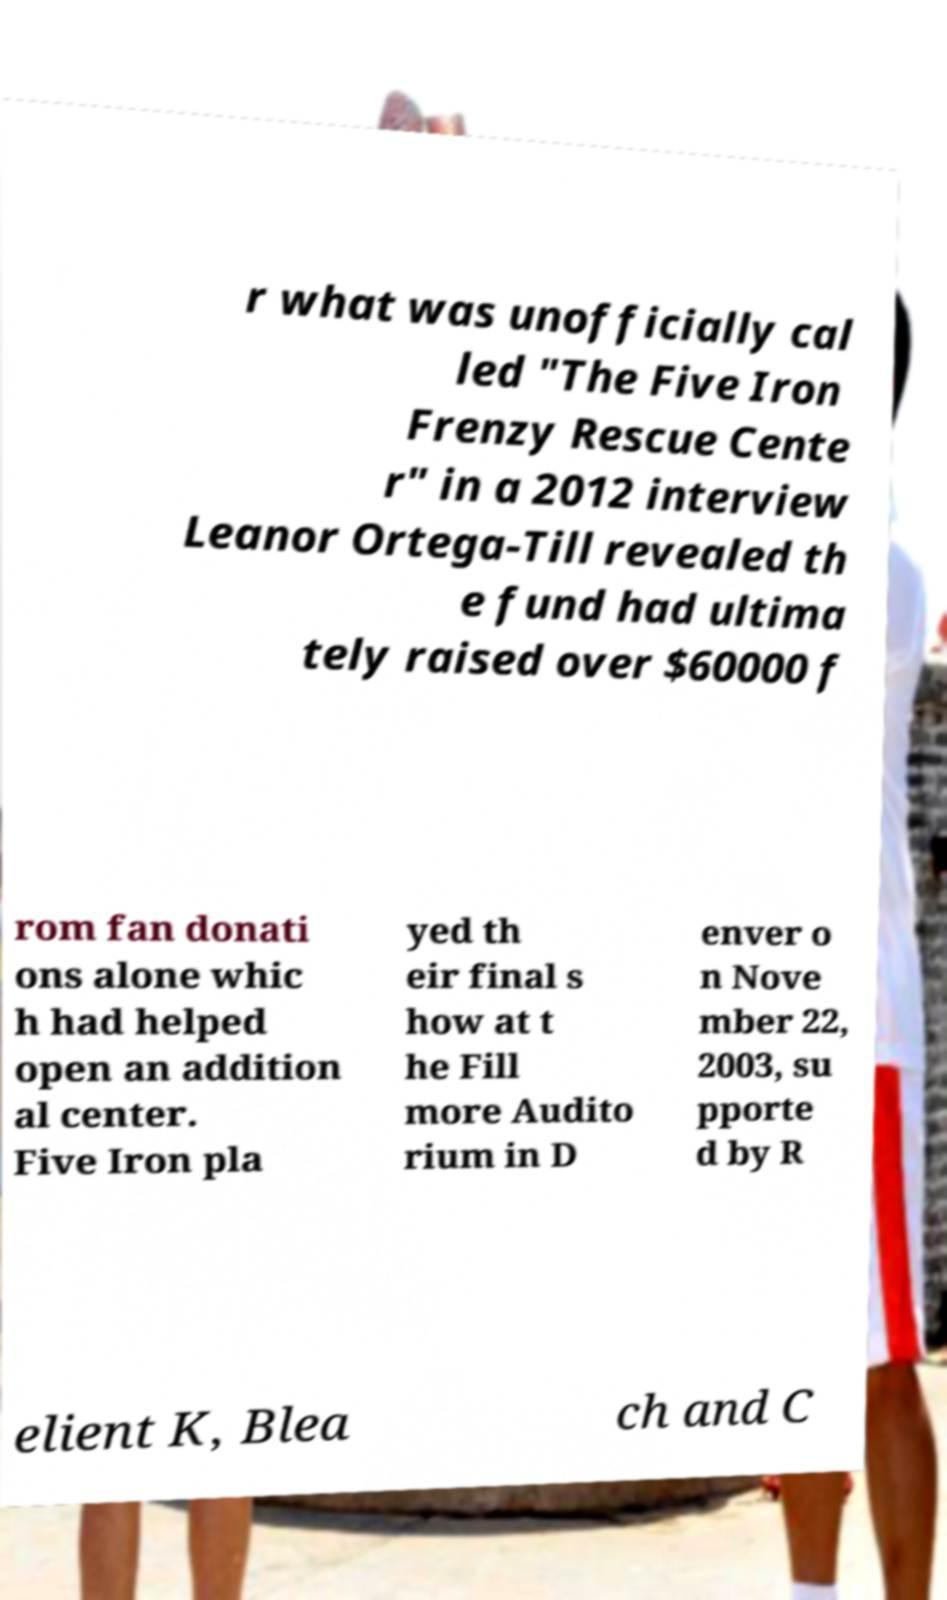Could you assist in decoding the text presented in this image and type it out clearly? r what was unofficially cal led "The Five Iron Frenzy Rescue Cente r" in a 2012 interview Leanor Ortega-Till revealed th e fund had ultima tely raised over $60000 f rom fan donati ons alone whic h had helped open an addition al center. Five Iron pla yed th eir final s how at t he Fill more Audito rium in D enver o n Nove mber 22, 2003, su pporte d by R elient K, Blea ch and C 